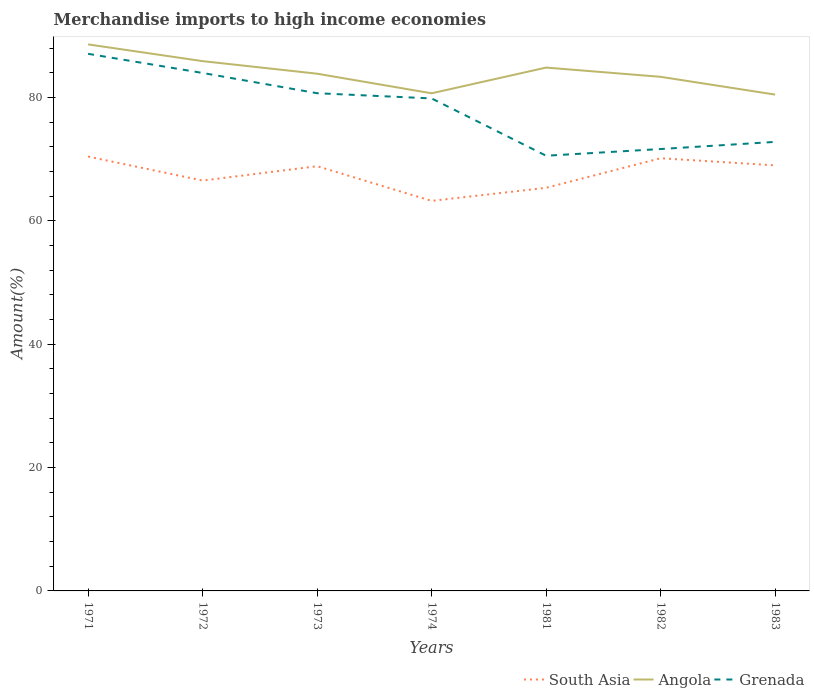Is the number of lines equal to the number of legend labels?
Provide a short and direct response. Yes. Across all years, what is the maximum percentage of amount earned from merchandise imports in Grenada?
Ensure brevity in your answer.  70.55. In which year was the percentage of amount earned from merchandise imports in Angola maximum?
Ensure brevity in your answer.  1983. What is the total percentage of amount earned from merchandise imports in Angola in the graph?
Offer a very short reply. -0.99. What is the difference between the highest and the second highest percentage of amount earned from merchandise imports in Grenada?
Provide a succinct answer. 16.52. Is the percentage of amount earned from merchandise imports in Angola strictly greater than the percentage of amount earned from merchandise imports in South Asia over the years?
Provide a succinct answer. No. How many lines are there?
Make the answer very short. 3. What is the difference between two consecutive major ticks on the Y-axis?
Give a very brief answer. 20. How are the legend labels stacked?
Your response must be concise. Horizontal. What is the title of the graph?
Offer a terse response. Merchandise imports to high income economies. What is the label or title of the X-axis?
Your answer should be compact. Years. What is the label or title of the Y-axis?
Your answer should be very brief. Amount(%). What is the Amount(%) in South Asia in 1971?
Make the answer very short. 70.42. What is the Amount(%) in Angola in 1971?
Your answer should be very brief. 88.6. What is the Amount(%) in Grenada in 1971?
Give a very brief answer. 87.07. What is the Amount(%) of South Asia in 1972?
Offer a very short reply. 66.53. What is the Amount(%) in Angola in 1972?
Give a very brief answer. 85.89. What is the Amount(%) of Grenada in 1972?
Your response must be concise. 83.97. What is the Amount(%) of South Asia in 1973?
Keep it short and to the point. 68.86. What is the Amount(%) in Angola in 1973?
Offer a very short reply. 83.85. What is the Amount(%) in Grenada in 1973?
Make the answer very short. 80.69. What is the Amount(%) in South Asia in 1974?
Offer a very short reply. 63.23. What is the Amount(%) in Angola in 1974?
Your response must be concise. 80.67. What is the Amount(%) in Grenada in 1974?
Offer a very short reply. 79.84. What is the Amount(%) of South Asia in 1981?
Ensure brevity in your answer.  65.35. What is the Amount(%) in Angola in 1981?
Provide a succinct answer. 84.84. What is the Amount(%) of Grenada in 1981?
Ensure brevity in your answer.  70.55. What is the Amount(%) in South Asia in 1982?
Your response must be concise. 70.14. What is the Amount(%) of Angola in 1982?
Offer a very short reply. 83.34. What is the Amount(%) of Grenada in 1982?
Keep it short and to the point. 71.64. What is the Amount(%) of South Asia in 1983?
Your response must be concise. 68.99. What is the Amount(%) in Angola in 1983?
Offer a very short reply. 80.46. What is the Amount(%) in Grenada in 1983?
Provide a short and direct response. 72.8. Across all years, what is the maximum Amount(%) of South Asia?
Keep it short and to the point. 70.42. Across all years, what is the maximum Amount(%) of Angola?
Your answer should be compact. 88.6. Across all years, what is the maximum Amount(%) in Grenada?
Your response must be concise. 87.07. Across all years, what is the minimum Amount(%) of South Asia?
Make the answer very short. 63.23. Across all years, what is the minimum Amount(%) of Angola?
Your answer should be very brief. 80.46. Across all years, what is the minimum Amount(%) of Grenada?
Ensure brevity in your answer.  70.55. What is the total Amount(%) in South Asia in the graph?
Your response must be concise. 473.52. What is the total Amount(%) in Angola in the graph?
Give a very brief answer. 587.66. What is the total Amount(%) of Grenada in the graph?
Provide a succinct answer. 546.56. What is the difference between the Amount(%) of South Asia in 1971 and that in 1972?
Offer a terse response. 3.89. What is the difference between the Amount(%) in Angola in 1971 and that in 1972?
Keep it short and to the point. 2.71. What is the difference between the Amount(%) of Grenada in 1971 and that in 1972?
Provide a short and direct response. 3.11. What is the difference between the Amount(%) of South Asia in 1971 and that in 1973?
Provide a short and direct response. 1.56. What is the difference between the Amount(%) of Angola in 1971 and that in 1973?
Make the answer very short. 4.75. What is the difference between the Amount(%) in Grenada in 1971 and that in 1973?
Offer a very short reply. 6.39. What is the difference between the Amount(%) of South Asia in 1971 and that in 1974?
Provide a short and direct response. 7.18. What is the difference between the Amount(%) in Angola in 1971 and that in 1974?
Your answer should be compact. 7.93. What is the difference between the Amount(%) in Grenada in 1971 and that in 1974?
Your response must be concise. 7.23. What is the difference between the Amount(%) of South Asia in 1971 and that in 1981?
Provide a succinct answer. 5.06. What is the difference between the Amount(%) of Angola in 1971 and that in 1981?
Provide a succinct answer. 3.76. What is the difference between the Amount(%) in Grenada in 1971 and that in 1981?
Offer a terse response. 16.52. What is the difference between the Amount(%) in South Asia in 1971 and that in 1982?
Offer a very short reply. 0.27. What is the difference between the Amount(%) of Angola in 1971 and that in 1982?
Make the answer very short. 5.26. What is the difference between the Amount(%) in Grenada in 1971 and that in 1982?
Offer a very short reply. 15.44. What is the difference between the Amount(%) in South Asia in 1971 and that in 1983?
Provide a short and direct response. 1.43. What is the difference between the Amount(%) in Angola in 1971 and that in 1983?
Provide a succinct answer. 8.14. What is the difference between the Amount(%) in Grenada in 1971 and that in 1983?
Provide a succinct answer. 14.28. What is the difference between the Amount(%) in South Asia in 1972 and that in 1973?
Ensure brevity in your answer.  -2.33. What is the difference between the Amount(%) in Angola in 1972 and that in 1973?
Offer a terse response. 2.04. What is the difference between the Amount(%) of Grenada in 1972 and that in 1973?
Give a very brief answer. 3.28. What is the difference between the Amount(%) of South Asia in 1972 and that in 1974?
Offer a very short reply. 3.29. What is the difference between the Amount(%) of Angola in 1972 and that in 1974?
Provide a short and direct response. 5.21. What is the difference between the Amount(%) of Grenada in 1972 and that in 1974?
Your response must be concise. 4.13. What is the difference between the Amount(%) in South Asia in 1972 and that in 1981?
Provide a succinct answer. 1.17. What is the difference between the Amount(%) of Angola in 1972 and that in 1981?
Offer a very short reply. 1.04. What is the difference between the Amount(%) in Grenada in 1972 and that in 1981?
Offer a very short reply. 13.42. What is the difference between the Amount(%) in South Asia in 1972 and that in 1982?
Your answer should be very brief. -3.62. What is the difference between the Amount(%) in Angola in 1972 and that in 1982?
Ensure brevity in your answer.  2.54. What is the difference between the Amount(%) in Grenada in 1972 and that in 1982?
Your answer should be very brief. 12.33. What is the difference between the Amount(%) of South Asia in 1972 and that in 1983?
Provide a succinct answer. -2.47. What is the difference between the Amount(%) of Angola in 1972 and that in 1983?
Ensure brevity in your answer.  5.43. What is the difference between the Amount(%) in Grenada in 1972 and that in 1983?
Provide a succinct answer. 11.17. What is the difference between the Amount(%) of South Asia in 1973 and that in 1974?
Your answer should be compact. 5.62. What is the difference between the Amount(%) of Angola in 1973 and that in 1974?
Ensure brevity in your answer.  3.18. What is the difference between the Amount(%) in Grenada in 1973 and that in 1974?
Provide a succinct answer. 0.84. What is the difference between the Amount(%) of South Asia in 1973 and that in 1981?
Offer a very short reply. 3.5. What is the difference between the Amount(%) of Angola in 1973 and that in 1981?
Offer a terse response. -0.99. What is the difference between the Amount(%) in Grenada in 1973 and that in 1981?
Make the answer very short. 10.13. What is the difference between the Amount(%) of South Asia in 1973 and that in 1982?
Make the answer very short. -1.29. What is the difference between the Amount(%) of Angola in 1973 and that in 1982?
Your response must be concise. 0.51. What is the difference between the Amount(%) in Grenada in 1973 and that in 1982?
Give a very brief answer. 9.05. What is the difference between the Amount(%) of South Asia in 1973 and that in 1983?
Offer a terse response. -0.13. What is the difference between the Amount(%) of Angola in 1973 and that in 1983?
Provide a succinct answer. 3.39. What is the difference between the Amount(%) of Grenada in 1973 and that in 1983?
Ensure brevity in your answer.  7.89. What is the difference between the Amount(%) in South Asia in 1974 and that in 1981?
Your answer should be compact. -2.12. What is the difference between the Amount(%) in Angola in 1974 and that in 1981?
Your answer should be compact. -4.17. What is the difference between the Amount(%) in Grenada in 1974 and that in 1981?
Keep it short and to the point. 9.29. What is the difference between the Amount(%) of South Asia in 1974 and that in 1982?
Ensure brevity in your answer.  -6.91. What is the difference between the Amount(%) of Angola in 1974 and that in 1982?
Offer a very short reply. -2.67. What is the difference between the Amount(%) of Grenada in 1974 and that in 1982?
Offer a very short reply. 8.2. What is the difference between the Amount(%) of South Asia in 1974 and that in 1983?
Make the answer very short. -5.76. What is the difference between the Amount(%) in Angola in 1974 and that in 1983?
Offer a terse response. 0.21. What is the difference between the Amount(%) in Grenada in 1974 and that in 1983?
Your answer should be very brief. 7.04. What is the difference between the Amount(%) of South Asia in 1981 and that in 1982?
Your answer should be very brief. -4.79. What is the difference between the Amount(%) in Angola in 1981 and that in 1982?
Your answer should be compact. 1.5. What is the difference between the Amount(%) in Grenada in 1981 and that in 1982?
Your answer should be compact. -1.09. What is the difference between the Amount(%) of South Asia in 1981 and that in 1983?
Ensure brevity in your answer.  -3.64. What is the difference between the Amount(%) of Angola in 1981 and that in 1983?
Your response must be concise. 4.38. What is the difference between the Amount(%) of Grenada in 1981 and that in 1983?
Make the answer very short. -2.25. What is the difference between the Amount(%) of South Asia in 1982 and that in 1983?
Your answer should be very brief. 1.15. What is the difference between the Amount(%) of Angola in 1982 and that in 1983?
Make the answer very short. 2.88. What is the difference between the Amount(%) of Grenada in 1982 and that in 1983?
Provide a short and direct response. -1.16. What is the difference between the Amount(%) in South Asia in 1971 and the Amount(%) in Angola in 1972?
Provide a short and direct response. -15.47. What is the difference between the Amount(%) of South Asia in 1971 and the Amount(%) of Grenada in 1972?
Keep it short and to the point. -13.55. What is the difference between the Amount(%) of Angola in 1971 and the Amount(%) of Grenada in 1972?
Ensure brevity in your answer.  4.63. What is the difference between the Amount(%) in South Asia in 1971 and the Amount(%) in Angola in 1973?
Keep it short and to the point. -13.43. What is the difference between the Amount(%) in South Asia in 1971 and the Amount(%) in Grenada in 1973?
Your answer should be compact. -10.27. What is the difference between the Amount(%) in Angola in 1971 and the Amount(%) in Grenada in 1973?
Your response must be concise. 7.91. What is the difference between the Amount(%) in South Asia in 1971 and the Amount(%) in Angola in 1974?
Offer a terse response. -10.26. What is the difference between the Amount(%) of South Asia in 1971 and the Amount(%) of Grenada in 1974?
Give a very brief answer. -9.42. What is the difference between the Amount(%) of Angola in 1971 and the Amount(%) of Grenada in 1974?
Offer a very short reply. 8.76. What is the difference between the Amount(%) of South Asia in 1971 and the Amount(%) of Angola in 1981?
Your response must be concise. -14.43. What is the difference between the Amount(%) of South Asia in 1971 and the Amount(%) of Grenada in 1981?
Your answer should be compact. -0.13. What is the difference between the Amount(%) of Angola in 1971 and the Amount(%) of Grenada in 1981?
Provide a succinct answer. 18.05. What is the difference between the Amount(%) in South Asia in 1971 and the Amount(%) in Angola in 1982?
Your response must be concise. -12.93. What is the difference between the Amount(%) of South Asia in 1971 and the Amount(%) of Grenada in 1982?
Your answer should be compact. -1.22. What is the difference between the Amount(%) of Angola in 1971 and the Amount(%) of Grenada in 1982?
Ensure brevity in your answer.  16.96. What is the difference between the Amount(%) of South Asia in 1971 and the Amount(%) of Angola in 1983?
Ensure brevity in your answer.  -10.04. What is the difference between the Amount(%) in South Asia in 1971 and the Amount(%) in Grenada in 1983?
Make the answer very short. -2.38. What is the difference between the Amount(%) in Angola in 1971 and the Amount(%) in Grenada in 1983?
Offer a very short reply. 15.8. What is the difference between the Amount(%) of South Asia in 1972 and the Amount(%) of Angola in 1973?
Make the answer very short. -17.33. What is the difference between the Amount(%) of South Asia in 1972 and the Amount(%) of Grenada in 1973?
Offer a terse response. -14.16. What is the difference between the Amount(%) of Angola in 1972 and the Amount(%) of Grenada in 1973?
Keep it short and to the point. 5.2. What is the difference between the Amount(%) in South Asia in 1972 and the Amount(%) in Angola in 1974?
Provide a succinct answer. -14.15. What is the difference between the Amount(%) of South Asia in 1972 and the Amount(%) of Grenada in 1974?
Your answer should be compact. -13.32. What is the difference between the Amount(%) of Angola in 1972 and the Amount(%) of Grenada in 1974?
Offer a very short reply. 6.05. What is the difference between the Amount(%) of South Asia in 1972 and the Amount(%) of Angola in 1981?
Your answer should be compact. -18.32. What is the difference between the Amount(%) in South Asia in 1972 and the Amount(%) in Grenada in 1981?
Your response must be concise. -4.03. What is the difference between the Amount(%) of Angola in 1972 and the Amount(%) of Grenada in 1981?
Your response must be concise. 15.34. What is the difference between the Amount(%) in South Asia in 1972 and the Amount(%) in Angola in 1982?
Ensure brevity in your answer.  -16.82. What is the difference between the Amount(%) of South Asia in 1972 and the Amount(%) of Grenada in 1982?
Ensure brevity in your answer.  -5.11. What is the difference between the Amount(%) in Angola in 1972 and the Amount(%) in Grenada in 1982?
Make the answer very short. 14.25. What is the difference between the Amount(%) of South Asia in 1972 and the Amount(%) of Angola in 1983?
Keep it short and to the point. -13.94. What is the difference between the Amount(%) of South Asia in 1972 and the Amount(%) of Grenada in 1983?
Make the answer very short. -6.27. What is the difference between the Amount(%) of Angola in 1972 and the Amount(%) of Grenada in 1983?
Offer a very short reply. 13.09. What is the difference between the Amount(%) in South Asia in 1973 and the Amount(%) in Angola in 1974?
Provide a succinct answer. -11.82. What is the difference between the Amount(%) in South Asia in 1973 and the Amount(%) in Grenada in 1974?
Offer a very short reply. -10.98. What is the difference between the Amount(%) in Angola in 1973 and the Amount(%) in Grenada in 1974?
Offer a terse response. 4.01. What is the difference between the Amount(%) in South Asia in 1973 and the Amount(%) in Angola in 1981?
Give a very brief answer. -15.99. What is the difference between the Amount(%) in South Asia in 1973 and the Amount(%) in Grenada in 1981?
Give a very brief answer. -1.69. What is the difference between the Amount(%) of Angola in 1973 and the Amount(%) of Grenada in 1981?
Ensure brevity in your answer.  13.3. What is the difference between the Amount(%) of South Asia in 1973 and the Amount(%) of Angola in 1982?
Your answer should be very brief. -14.49. What is the difference between the Amount(%) of South Asia in 1973 and the Amount(%) of Grenada in 1982?
Give a very brief answer. -2.78. What is the difference between the Amount(%) of Angola in 1973 and the Amount(%) of Grenada in 1982?
Your answer should be compact. 12.21. What is the difference between the Amount(%) in South Asia in 1973 and the Amount(%) in Angola in 1983?
Ensure brevity in your answer.  -11.61. What is the difference between the Amount(%) of South Asia in 1973 and the Amount(%) of Grenada in 1983?
Provide a succinct answer. -3.94. What is the difference between the Amount(%) of Angola in 1973 and the Amount(%) of Grenada in 1983?
Provide a short and direct response. 11.05. What is the difference between the Amount(%) in South Asia in 1974 and the Amount(%) in Angola in 1981?
Your answer should be very brief. -21.61. What is the difference between the Amount(%) in South Asia in 1974 and the Amount(%) in Grenada in 1981?
Offer a very short reply. -7.32. What is the difference between the Amount(%) of Angola in 1974 and the Amount(%) of Grenada in 1981?
Offer a very short reply. 10.12. What is the difference between the Amount(%) of South Asia in 1974 and the Amount(%) of Angola in 1982?
Ensure brevity in your answer.  -20.11. What is the difference between the Amount(%) in South Asia in 1974 and the Amount(%) in Grenada in 1982?
Your answer should be very brief. -8.41. What is the difference between the Amount(%) of Angola in 1974 and the Amount(%) of Grenada in 1982?
Ensure brevity in your answer.  9.03. What is the difference between the Amount(%) of South Asia in 1974 and the Amount(%) of Angola in 1983?
Your answer should be compact. -17.23. What is the difference between the Amount(%) of South Asia in 1974 and the Amount(%) of Grenada in 1983?
Make the answer very short. -9.57. What is the difference between the Amount(%) in Angola in 1974 and the Amount(%) in Grenada in 1983?
Keep it short and to the point. 7.88. What is the difference between the Amount(%) in South Asia in 1981 and the Amount(%) in Angola in 1982?
Offer a terse response. -17.99. What is the difference between the Amount(%) of South Asia in 1981 and the Amount(%) of Grenada in 1982?
Your answer should be compact. -6.29. What is the difference between the Amount(%) of Angola in 1981 and the Amount(%) of Grenada in 1982?
Offer a very short reply. 13.2. What is the difference between the Amount(%) in South Asia in 1981 and the Amount(%) in Angola in 1983?
Give a very brief answer. -15.11. What is the difference between the Amount(%) in South Asia in 1981 and the Amount(%) in Grenada in 1983?
Ensure brevity in your answer.  -7.45. What is the difference between the Amount(%) of Angola in 1981 and the Amount(%) of Grenada in 1983?
Your answer should be very brief. 12.05. What is the difference between the Amount(%) in South Asia in 1982 and the Amount(%) in Angola in 1983?
Provide a succinct answer. -10.32. What is the difference between the Amount(%) in South Asia in 1982 and the Amount(%) in Grenada in 1983?
Your response must be concise. -2.65. What is the difference between the Amount(%) of Angola in 1982 and the Amount(%) of Grenada in 1983?
Offer a very short reply. 10.55. What is the average Amount(%) in South Asia per year?
Your answer should be very brief. 67.65. What is the average Amount(%) of Angola per year?
Provide a short and direct response. 83.95. What is the average Amount(%) of Grenada per year?
Keep it short and to the point. 78.08. In the year 1971, what is the difference between the Amount(%) in South Asia and Amount(%) in Angola?
Offer a very short reply. -18.18. In the year 1971, what is the difference between the Amount(%) of South Asia and Amount(%) of Grenada?
Keep it short and to the point. -16.66. In the year 1971, what is the difference between the Amount(%) in Angola and Amount(%) in Grenada?
Your response must be concise. 1.53. In the year 1972, what is the difference between the Amount(%) of South Asia and Amount(%) of Angola?
Your answer should be compact. -19.36. In the year 1972, what is the difference between the Amount(%) in South Asia and Amount(%) in Grenada?
Make the answer very short. -17.44. In the year 1972, what is the difference between the Amount(%) in Angola and Amount(%) in Grenada?
Make the answer very short. 1.92. In the year 1973, what is the difference between the Amount(%) in South Asia and Amount(%) in Angola?
Provide a short and direct response. -14.99. In the year 1973, what is the difference between the Amount(%) in South Asia and Amount(%) in Grenada?
Your answer should be very brief. -11.83. In the year 1973, what is the difference between the Amount(%) in Angola and Amount(%) in Grenada?
Provide a succinct answer. 3.17. In the year 1974, what is the difference between the Amount(%) of South Asia and Amount(%) of Angola?
Your answer should be compact. -17.44. In the year 1974, what is the difference between the Amount(%) in South Asia and Amount(%) in Grenada?
Offer a terse response. -16.61. In the year 1974, what is the difference between the Amount(%) in Angola and Amount(%) in Grenada?
Offer a very short reply. 0.83. In the year 1981, what is the difference between the Amount(%) of South Asia and Amount(%) of Angola?
Your answer should be very brief. -19.49. In the year 1981, what is the difference between the Amount(%) of South Asia and Amount(%) of Grenada?
Provide a succinct answer. -5.2. In the year 1981, what is the difference between the Amount(%) in Angola and Amount(%) in Grenada?
Your answer should be compact. 14.29. In the year 1982, what is the difference between the Amount(%) of South Asia and Amount(%) of Angola?
Offer a very short reply. -13.2. In the year 1982, what is the difference between the Amount(%) in South Asia and Amount(%) in Grenada?
Make the answer very short. -1.49. In the year 1982, what is the difference between the Amount(%) in Angola and Amount(%) in Grenada?
Provide a short and direct response. 11.71. In the year 1983, what is the difference between the Amount(%) of South Asia and Amount(%) of Angola?
Give a very brief answer. -11.47. In the year 1983, what is the difference between the Amount(%) in South Asia and Amount(%) in Grenada?
Make the answer very short. -3.81. In the year 1983, what is the difference between the Amount(%) in Angola and Amount(%) in Grenada?
Offer a very short reply. 7.66. What is the ratio of the Amount(%) of South Asia in 1971 to that in 1972?
Offer a very short reply. 1.06. What is the ratio of the Amount(%) in Angola in 1971 to that in 1972?
Your response must be concise. 1.03. What is the ratio of the Amount(%) of Grenada in 1971 to that in 1972?
Your answer should be compact. 1.04. What is the ratio of the Amount(%) in South Asia in 1971 to that in 1973?
Provide a succinct answer. 1.02. What is the ratio of the Amount(%) of Angola in 1971 to that in 1973?
Give a very brief answer. 1.06. What is the ratio of the Amount(%) in Grenada in 1971 to that in 1973?
Ensure brevity in your answer.  1.08. What is the ratio of the Amount(%) in South Asia in 1971 to that in 1974?
Make the answer very short. 1.11. What is the ratio of the Amount(%) of Angola in 1971 to that in 1974?
Your answer should be very brief. 1.1. What is the ratio of the Amount(%) in Grenada in 1971 to that in 1974?
Keep it short and to the point. 1.09. What is the ratio of the Amount(%) in South Asia in 1971 to that in 1981?
Keep it short and to the point. 1.08. What is the ratio of the Amount(%) of Angola in 1971 to that in 1981?
Provide a short and direct response. 1.04. What is the ratio of the Amount(%) in Grenada in 1971 to that in 1981?
Provide a succinct answer. 1.23. What is the ratio of the Amount(%) of Angola in 1971 to that in 1982?
Make the answer very short. 1.06. What is the ratio of the Amount(%) in Grenada in 1971 to that in 1982?
Provide a short and direct response. 1.22. What is the ratio of the Amount(%) in South Asia in 1971 to that in 1983?
Keep it short and to the point. 1.02. What is the ratio of the Amount(%) of Angola in 1971 to that in 1983?
Keep it short and to the point. 1.1. What is the ratio of the Amount(%) of Grenada in 1971 to that in 1983?
Provide a short and direct response. 1.2. What is the ratio of the Amount(%) in South Asia in 1972 to that in 1973?
Your response must be concise. 0.97. What is the ratio of the Amount(%) in Angola in 1972 to that in 1973?
Offer a very short reply. 1.02. What is the ratio of the Amount(%) of Grenada in 1972 to that in 1973?
Your answer should be very brief. 1.04. What is the ratio of the Amount(%) of South Asia in 1972 to that in 1974?
Provide a short and direct response. 1.05. What is the ratio of the Amount(%) in Angola in 1972 to that in 1974?
Make the answer very short. 1.06. What is the ratio of the Amount(%) in Grenada in 1972 to that in 1974?
Make the answer very short. 1.05. What is the ratio of the Amount(%) of South Asia in 1972 to that in 1981?
Your answer should be very brief. 1.02. What is the ratio of the Amount(%) in Angola in 1972 to that in 1981?
Keep it short and to the point. 1.01. What is the ratio of the Amount(%) of Grenada in 1972 to that in 1981?
Offer a terse response. 1.19. What is the ratio of the Amount(%) of South Asia in 1972 to that in 1982?
Provide a short and direct response. 0.95. What is the ratio of the Amount(%) of Angola in 1972 to that in 1982?
Make the answer very short. 1.03. What is the ratio of the Amount(%) of Grenada in 1972 to that in 1982?
Make the answer very short. 1.17. What is the ratio of the Amount(%) of South Asia in 1972 to that in 1983?
Make the answer very short. 0.96. What is the ratio of the Amount(%) of Angola in 1972 to that in 1983?
Ensure brevity in your answer.  1.07. What is the ratio of the Amount(%) in Grenada in 1972 to that in 1983?
Offer a very short reply. 1.15. What is the ratio of the Amount(%) of South Asia in 1973 to that in 1974?
Provide a succinct answer. 1.09. What is the ratio of the Amount(%) in Angola in 1973 to that in 1974?
Your answer should be very brief. 1.04. What is the ratio of the Amount(%) in Grenada in 1973 to that in 1974?
Make the answer very short. 1.01. What is the ratio of the Amount(%) of South Asia in 1973 to that in 1981?
Give a very brief answer. 1.05. What is the ratio of the Amount(%) in Angola in 1973 to that in 1981?
Offer a very short reply. 0.99. What is the ratio of the Amount(%) of Grenada in 1973 to that in 1981?
Your answer should be compact. 1.14. What is the ratio of the Amount(%) of South Asia in 1973 to that in 1982?
Offer a very short reply. 0.98. What is the ratio of the Amount(%) of Grenada in 1973 to that in 1982?
Your answer should be compact. 1.13. What is the ratio of the Amount(%) in South Asia in 1973 to that in 1983?
Ensure brevity in your answer.  1. What is the ratio of the Amount(%) in Angola in 1973 to that in 1983?
Your answer should be compact. 1.04. What is the ratio of the Amount(%) of Grenada in 1973 to that in 1983?
Your response must be concise. 1.11. What is the ratio of the Amount(%) in South Asia in 1974 to that in 1981?
Ensure brevity in your answer.  0.97. What is the ratio of the Amount(%) in Angola in 1974 to that in 1981?
Make the answer very short. 0.95. What is the ratio of the Amount(%) of Grenada in 1974 to that in 1981?
Your answer should be very brief. 1.13. What is the ratio of the Amount(%) of South Asia in 1974 to that in 1982?
Keep it short and to the point. 0.9. What is the ratio of the Amount(%) in Angola in 1974 to that in 1982?
Ensure brevity in your answer.  0.97. What is the ratio of the Amount(%) of Grenada in 1974 to that in 1982?
Provide a short and direct response. 1.11. What is the ratio of the Amount(%) in South Asia in 1974 to that in 1983?
Your response must be concise. 0.92. What is the ratio of the Amount(%) of Grenada in 1974 to that in 1983?
Offer a very short reply. 1.1. What is the ratio of the Amount(%) in South Asia in 1981 to that in 1982?
Provide a succinct answer. 0.93. What is the ratio of the Amount(%) in Grenada in 1981 to that in 1982?
Your response must be concise. 0.98. What is the ratio of the Amount(%) of South Asia in 1981 to that in 1983?
Give a very brief answer. 0.95. What is the ratio of the Amount(%) in Angola in 1981 to that in 1983?
Your answer should be very brief. 1.05. What is the ratio of the Amount(%) in Grenada in 1981 to that in 1983?
Give a very brief answer. 0.97. What is the ratio of the Amount(%) in South Asia in 1982 to that in 1983?
Offer a terse response. 1.02. What is the ratio of the Amount(%) in Angola in 1982 to that in 1983?
Make the answer very short. 1.04. What is the ratio of the Amount(%) in Grenada in 1982 to that in 1983?
Ensure brevity in your answer.  0.98. What is the difference between the highest and the second highest Amount(%) of South Asia?
Give a very brief answer. 0.27. What is the difference between the highest and the second highest Amount(%) in Angola?
Your response must be concise. 2.71. What is the difference between the highest and the second highest Amount(%) of Grenada?
Make the answer very short. 3.11. What is the difference between the highest and the lowest Amount(%) in South Asia?
Your answer should be compact. 7.18. What is the difference between the highest and the lowest Amount(%) of Angola?
Give a very brief answer. 8.14. What is the difference between the highest and the lowest Amount(%) of Grenada?
Your response must be concise. 16.52. 